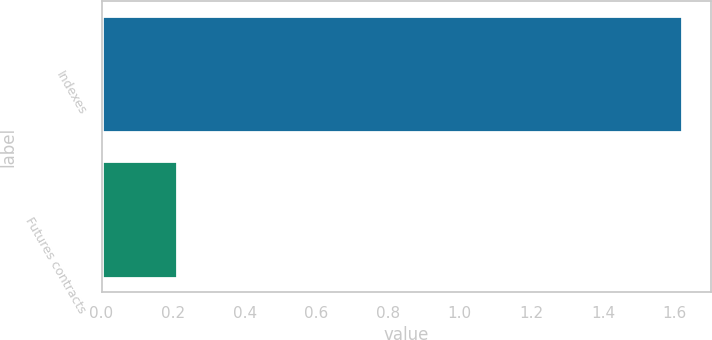Convert chart. <chart><loc_0><loc_0><loc_500><loc_500><bar_chart><fcel>Indexes<fcel>Futures contracts<nl><fcel>1.62<fcel>0.21<nl></chart> 